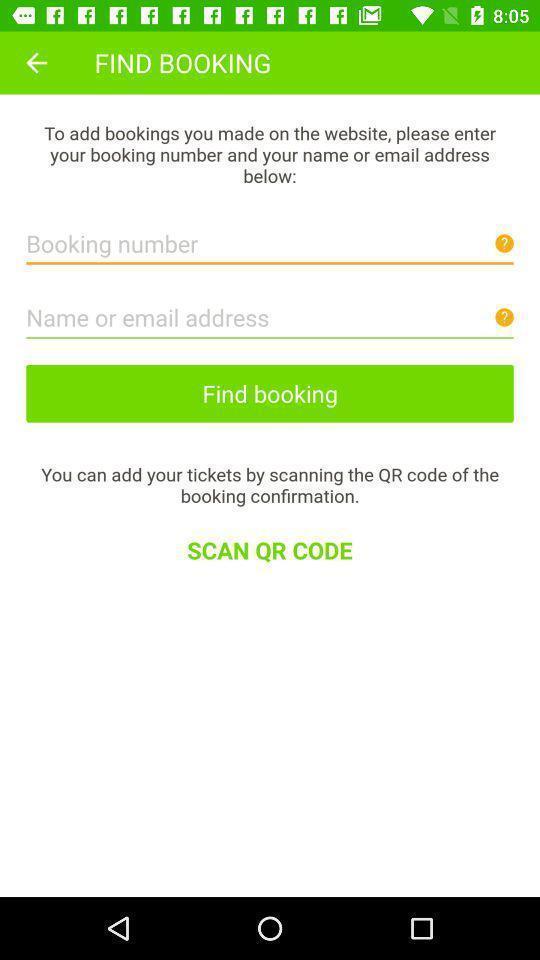Provide a textual representation of this image. Screen showing find bookings. 